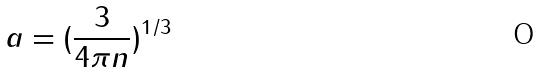Convert formula to latex. <formula><loc_0><loc_0><loc_500><loc_500>a = ( \frac { 3 } { 4 \pi n } ) ^ { 1 / 3 }</formula> 